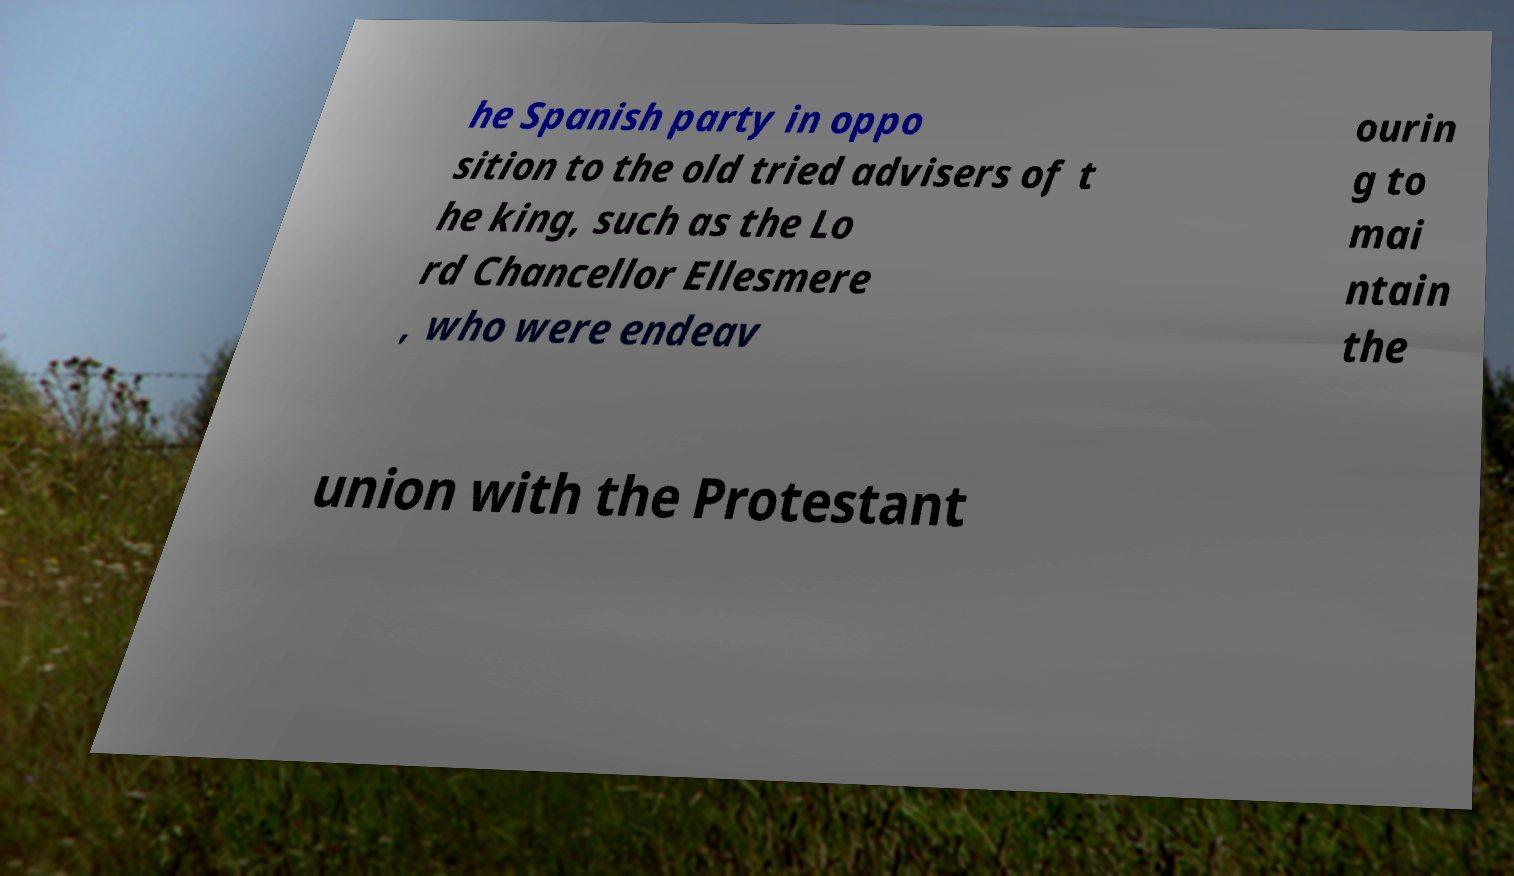I need the written content from this picture converted into text. Can you do that? he Spanish party in oppo sition to the old tried advisers of t he king, such as the Lo rd Chancellor Ellesmere , who were endeav ourin g to mai ntain the union with the Protestant 